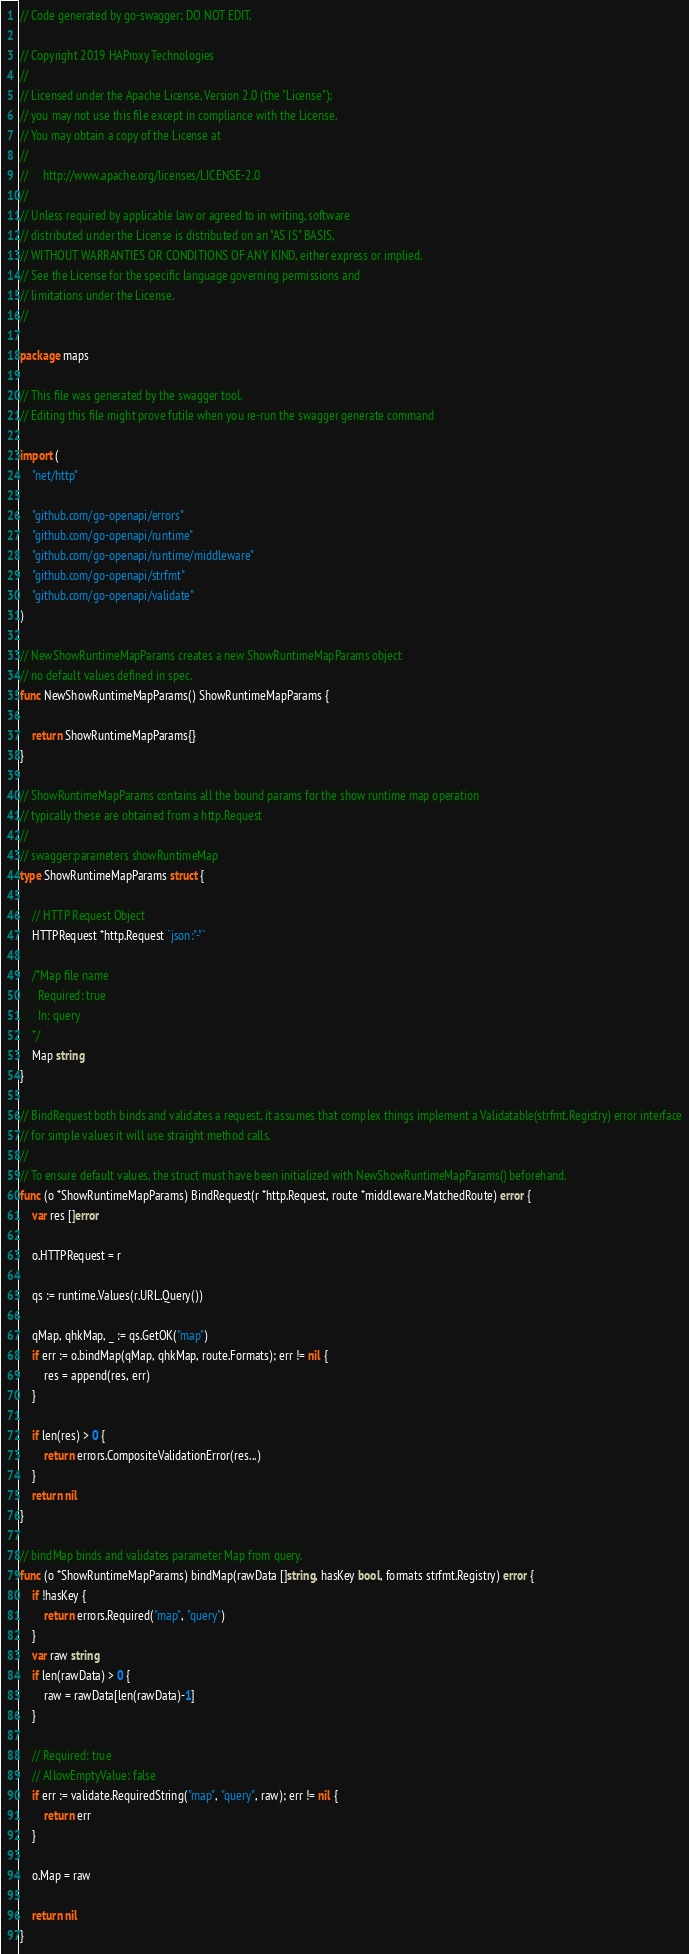Convert code to text. <code><loc_0><loc_0><loc_500><loc_500><_Go_>// Code generated by go-swagger; DO NOT EDIT.

// Copyright 2019 HAProxy Technologies
//
// Licensed under the Apache License, Version 2.0 (the "License");
// you may not use this file except in compliance with the License.
// You may obtain a copy of the License at
//
//     http://www.apache.org/licenses/LICENSE-2.0
//
// Unless required by applicable law or agreed to in writing, software
// distributed under the License is distributed on an "AS IS" BASIS,
// WITHOUT WARRANTIES OR CONDITIONS OF ANY KIND, either express or implied.
// See the License for the specific language governing permissions and
// limitations under the License.
//

package maps

// This file was generated by the swagger tool.
// Editing this file might prove futile when you re-run the swagger generate command

import (
	"net/http"

	"github.com/go-openapi/errors"
	"github.com/go-openapi/runtime"
	"github.com/go-openapi/runtime/middleware"
	"github.com/go-openapi/strfmt"
	"github.com/go-openapi/validate"
)

// NewShowRuntimeMapParams creates a new ShowRuntimeMapParams object
// no default values defined in spec.
func NewShowRuntimeMapParams() ShowRuntimeMapParams {

	return ShowRuntimeMapParams{}
}

// ShowRuntimeMapParams contains all the bound params for the show runtime map operation
// typically these are obtained from a http.Request
//
// swagger:parameters showRuntimeMap
type ShowRuntimeMapParams struct {

	// HTTP Request Object
	HTTPRequest *http.Request `json:"-"`

	/*Map file name
	  Required: true
	  In: query
	*/
	Map string
}

// BindRequest both binds and validates a request, it assumes that complex things implement a Validatable(strfmt.Registry) error interface
// for simple values it will use straight method calls.
//
// To ensure default values, the struct must have been initialized with NewShowRuntimeMapParams() beforehand.
func (o *ShowRuntimeMapParams) BindRequest(r *http.Request, route *middleware.MatchedRoute) error {
	var res []error

	o.HTTPRequest = r

	qs := runtime.Values(r.URL.Query())

	qMap, qhkMap, _ := qs.GetOK("map")
	if err := o.bindMap(qMap, qhkMap, route.Formats); err != nil {
		res = append(res, err)
	}

	if len(res) > 0 {
		return errors.CompositeValidationError(res...)
	}
	return nil
}

// bindMap binds and validates parameter Map from query.
func (o *ShowRuntimeMapParams) bindMap(rawData []string, hasKey bool, formats strfmt.Registry) error {
	if !hasKey {
		return errors.Required("map", "query")
	}
	var raw string
	if len(rawData) > 0 {
		raw = rawData[len(rawData)-1]
	}

	// Required: true
	// AllowEmptyValue: false
	if err := validate.RequiredString("map", "query", raw); err != nil {
		return err
	}

	o.Map = raw

	return nil
}
</code> 